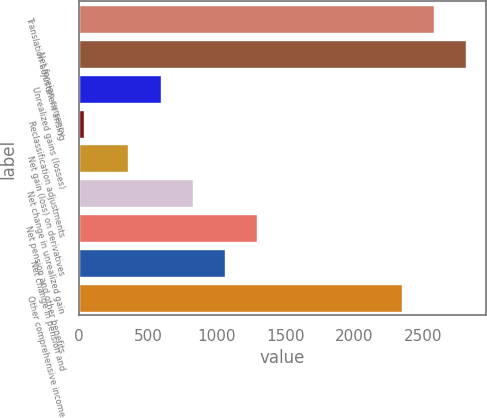<chart> <loc_0><loc_0><loc_500><loc_500><bar_chart><fcel>Translation adjustment arising<fcel>Net foreign currency<fcel>Unrealized gains (losses)<fcel>Reclassification adjustments<fcel>Net gain (loss) on derivatives<fcel>Net change in unrealized gain<fcel>Net pension and other benefits<fcel>Net change in pension and<fcel>Other comprehensive income<nl><fcel>2579.5<fcel>2814<fcel>591.5<fcel>32<fcel>357<fcel>826<fcel>1295<fcel>1060.5<fcel>2345<nl></chart> 